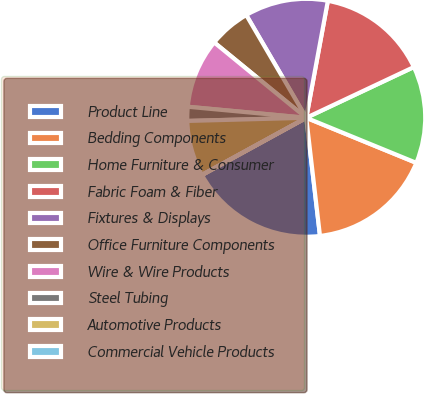Convert chart to OTSL. <chart><loc_0><loc_0><loc_500><loc_500><pie_chart><fcel>Product Line<fcel>Bedding Components<fcel>Home Furniture & Consumer<fcel>Fabric Foam & Fiber<fcel>Fixtures & Displays<fcel>Office Furniture Components<fcel>Wire & Wire Products<fcel>Steel Tubing<fcel>Automotive Products<fcel>Commercial Vehicle Products<nl><fcel>18.85%<fcel>16.97%<fcel>13.2%<fcel>15.08%<fcel>11.32%<fcel>5.67%<fcel>9.44%<fcel>1.9%<fcel>7.55%<fcel>0.02%<nl></chart> 